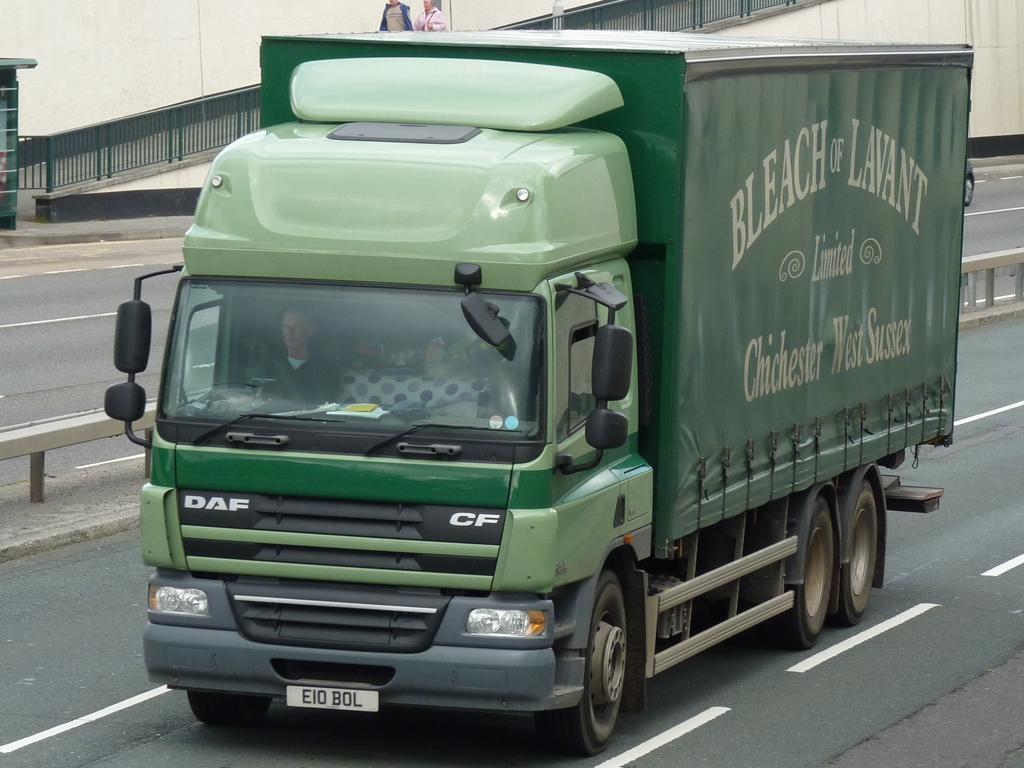How would you summarize this image in a sentence or two? In this picture I can observe green color truck on the road. I can observe a black color railing in the background. 